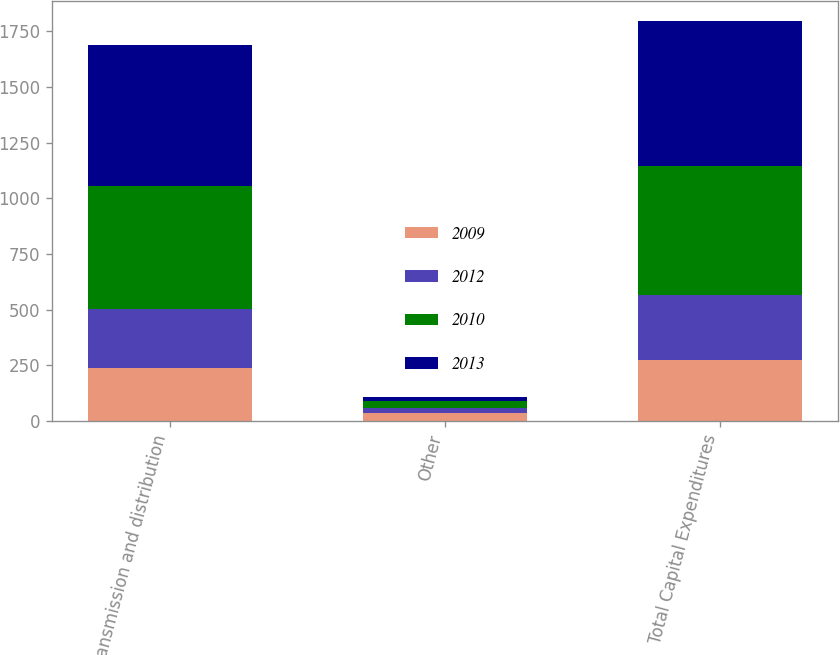Convert chart to OTSL. <chart><loc_0><loc_0><loc_500><loc_500><stacked_bar_chart><ecel><fcel>Transmission and distribution<fcel>Other<fcel>Total Capital Expenditures<nl><fcel>2009<fcel>237<fcel>38<fcel>275<nl><fcel>2012<fcel>267<fcel>22<fcel>289<nl><fcel>2010<fcel>553<fcel>29<fcel>582<nl><fcel>2013<fcel>630<fcel>19<fcel>649<nl></chart> 